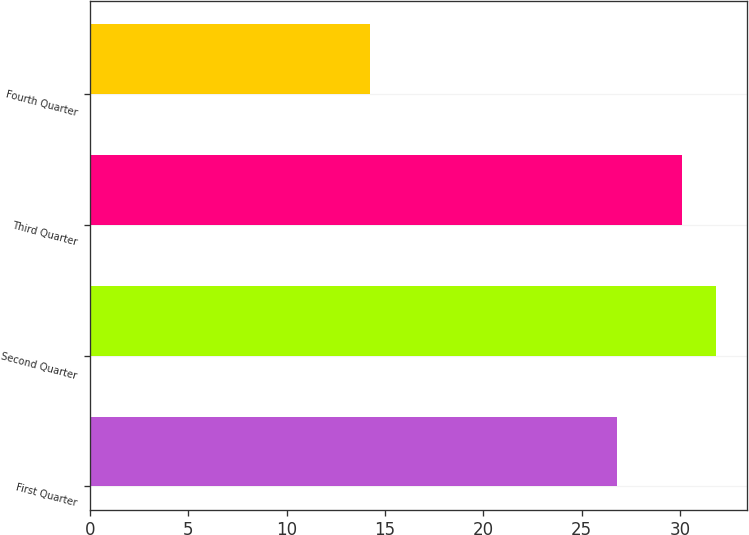Convert chart. <chart><loc_0><loc_0><loc_500><loc_500><bar_chart><fcel>First Quarter<fcel>Second Quarter<fcel>Third Quarter<fcel>Fourth Quarter<nl><fcel>26.8<fcel>31.81<fcel>30.12<fcel>14.26<nl></chart> 